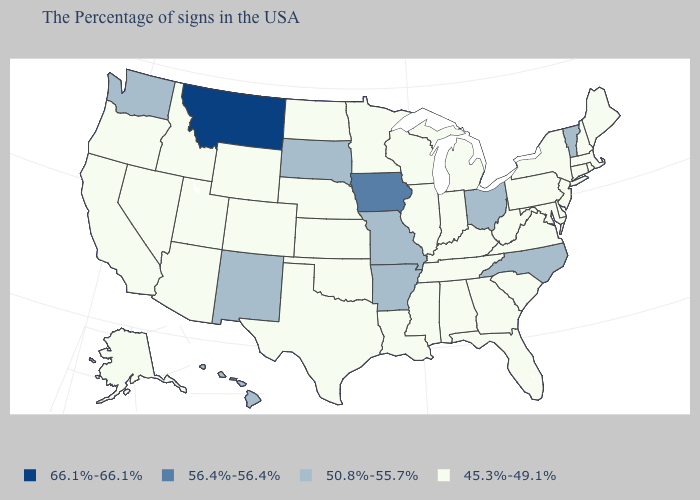Does Georgia have the lowest value in the South?
Write a very short answer. Yes. What is the value of Missouri?
Write a very short answer. 50.8%-55.7%. How many symbols are there in the legend?
Quick response, please. 4. Among the states that border Idaho , does Nevada have the lowest value?
Answer briefly. Yes. How many symbols are there in the legend?
Concise answer only. 4. Does the map have missing data?
Concise answer only. No. What is the value of Alabama?
Write a very short answer. 45.3%-49.1%. What is the value of Alabama?
Answer briefly. 45.3%-49.1%. Among the states that border Vermont , which have the lowest value?
Answer briefly. Massachusetts, New Hampshire, New York. Which states hav the highest value in the Northeast?
Answer briefly. Vermont. Name the states that have a value in the range 56.4%-56.4%?
Be succinct. Iowa. What is the highest value in the West ?
Concise answer only. 66.1%-66.1%. Which states have the highest value in the USA?
Keep it brief. Montana. What is the value of Minnesota?
Quick response, please. 45.3%-49.1%. What is the value of Wisconsin?
Write a very short answer. 45.3%-49.1%. 